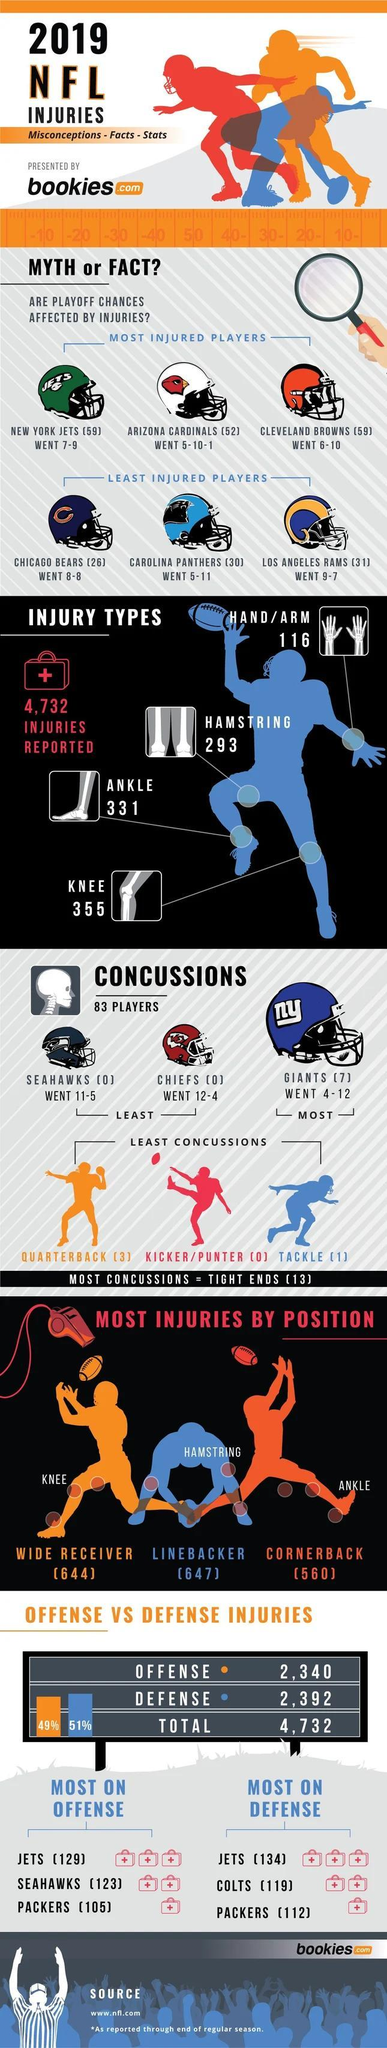How many NFL players has reported concussions during 2019 NFL games?
Answer the question with a short phrase. 83 PLAYERS How many 'Chicago Bears' players were injured during the 2019 NFL games? (26) Which NFL team has reported the most number of concussions in 2019 NFL games? G I A N T S What is written on the Giant's helmet? ny How many ankle injuries were reported during 2019 NFL games? 3 3 1 What is the total number of injuries reported in 2019 NFL games? 4,732 Which is the most reported injury type in players during 2019 NFL games? KNEE 